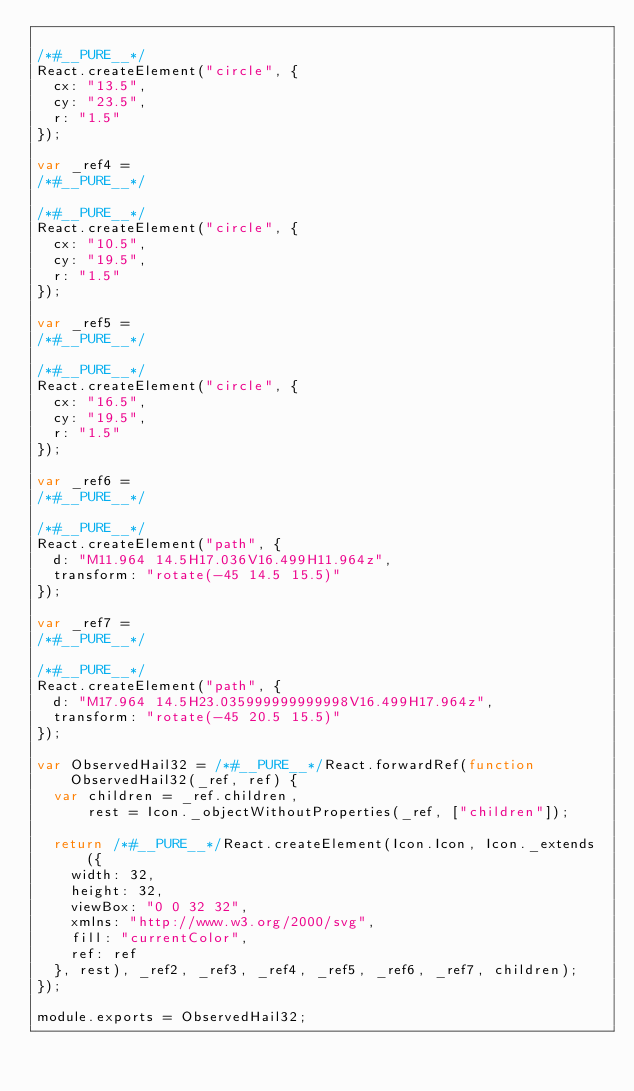Convert code to text. <code><loc_0><loc_0><loc_500><loc_500><_JavaScript_>
/*#__PURE__*/
React.createElement("circle", {
  cx: "13.5",
  cy: "23.5",
  r: "1.5"
});

var _ref4 =
/*#__PURE__*/

/*#__PURE__*/
React.createElement("circle", {
  cx: "10.5",
  cy: "19.5",
  r: "1.5"
});

var _ref5 =
/*#__PURE__*/

/*#__PURE__*/
React.createElement("circle", {
  cx: "16.5",
  cy: "19.5",
  r: "1.5"
});

var _ref6 =
/*#__PURE__*/

/*#__PURE__*/
React.createElement("path", {
  d: "M11.964 14.5H17.036V16.499H11.964z",
  transform: "rotate(-45 14.5 15.5)"
});

var _ref7 =
/*#__PURE__*/

/*#__PURE__*/
React.createElement("path", {
  d: "M17.964 14.5H23.035999999999998V16.499H17.964z",
  transform: "rotate(-45 20.5 15.5)"
});

var ObservedHail32 = /*#__PURE__*/React.forwardRef(function ObservedHail32(_ref, ref) {
  var children = _ref.children,
      rest = Icon._objectWithoutProperties(_ref, ["children"]);

  return /*#__PURE__*/React.createElement(Icon.Icon, Icon._extends({
    width: 32,
    height: 32,
    viewBox: "0 0 32 32",
    xmlns: "http://www.w3.org/2000/svg",
    fill: "currentColor",
    ref: ref
  }, rest), _ref2, _ref3, _ref4, _ref5, _ref6, _ref7, children);
});

module.exports = ObservedHail32;
</code> 